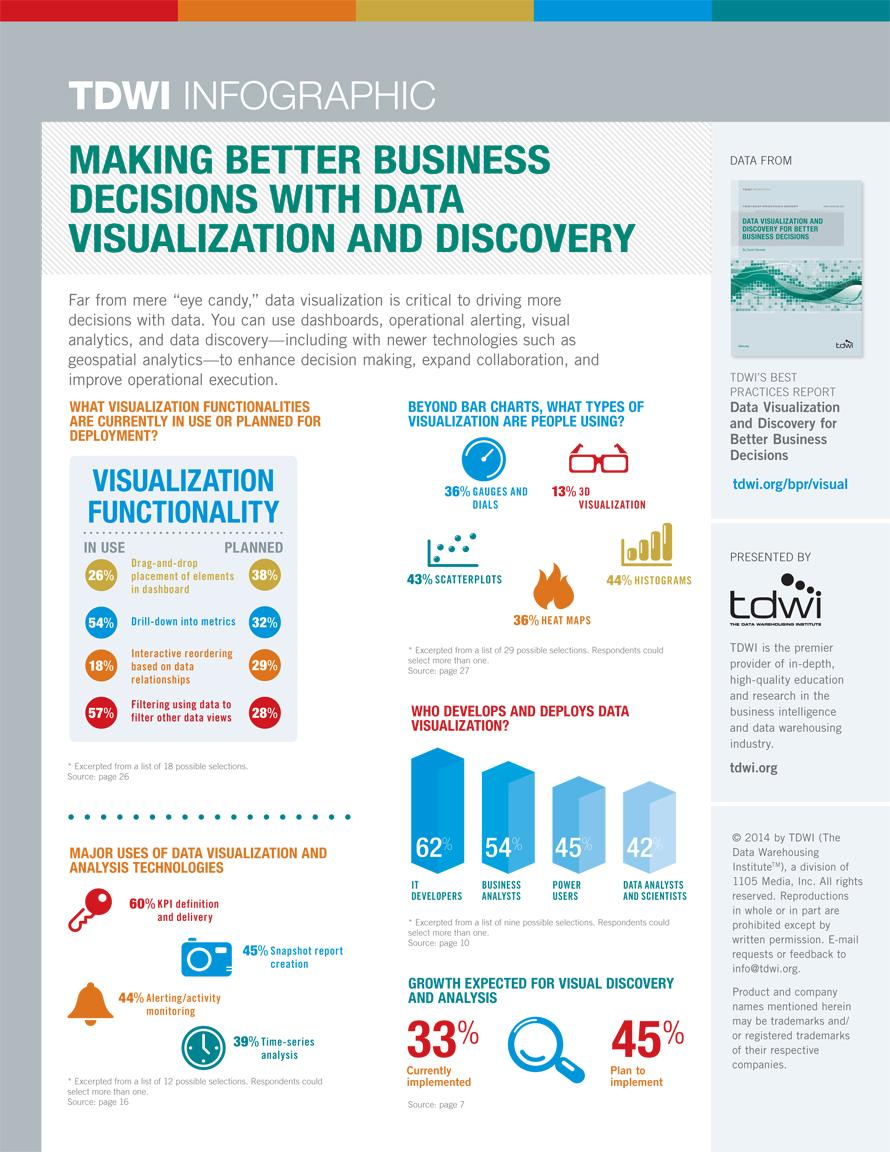Indicate a few pertinent items in this graphic. This infographic mentions 4 uses of data visualization and analysis technologies. According to a survey, 57% of people are not using scatterplots as a primary method of data visualization. According to a recent survey, 64% of individuals are not utilizing heat maps as a primary method of data visualization. According to a recent study, 87% of people are not using 3D visualization as a form of data visualization. A recent survey found that 64% of people are not using gauges and dials as a primary method of data visualization. 